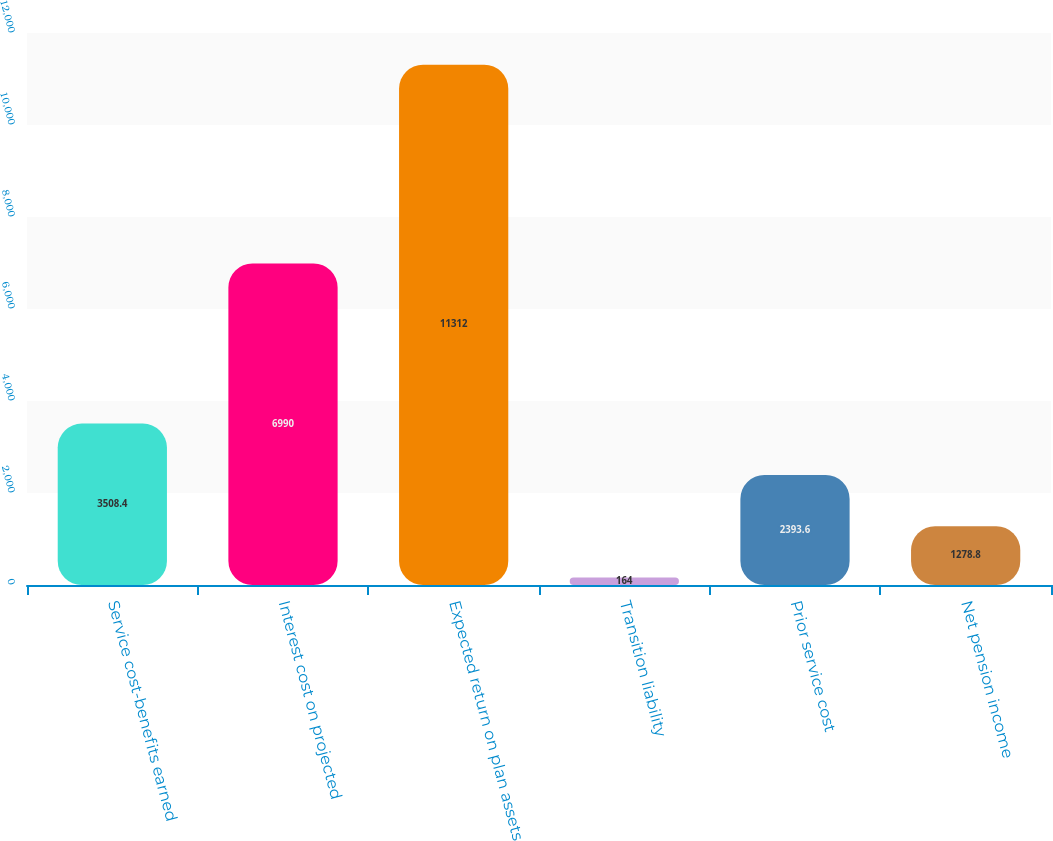Convert chart to OTSL. <chart><loc_0><loc_0><loc_500><loc_500><bar_chart><fcel>Service cost-benefits earned<fcel>Interest cost on projected<fcel>Expected return on plan assets<fcel>Transition liability<fcel>Prior service cost<fcel>Net pension income<nl><fcel>3508.4<fcel>6990<fcel>11312<fcel>164<fcel>2393.6<fcel>1278.8<nl></chart> 